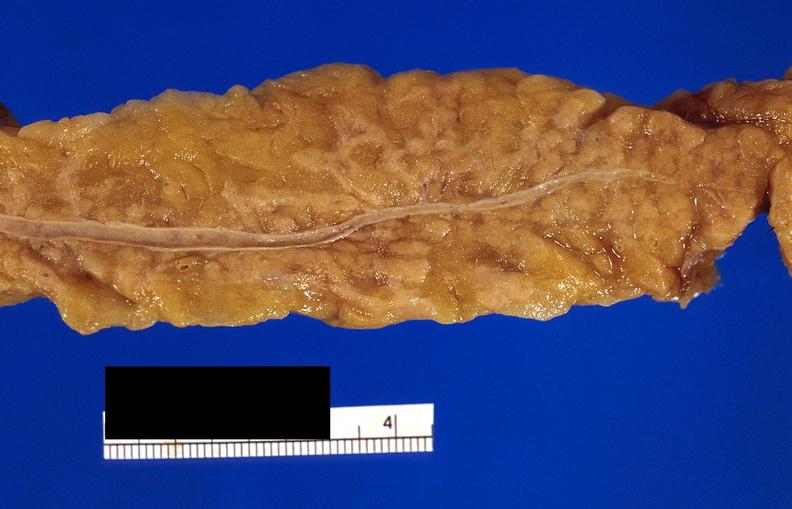does this image show pancreatic fat necrosis?
Answer the question using a single word or phrase. Yes 